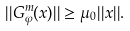<formula> <loc_0><loc_0><loc_500><loc_500>| | G ^ { m } _ { \varphi } ( x ) | | \geq \mu _ { 0 } | | x | | .</formula> 